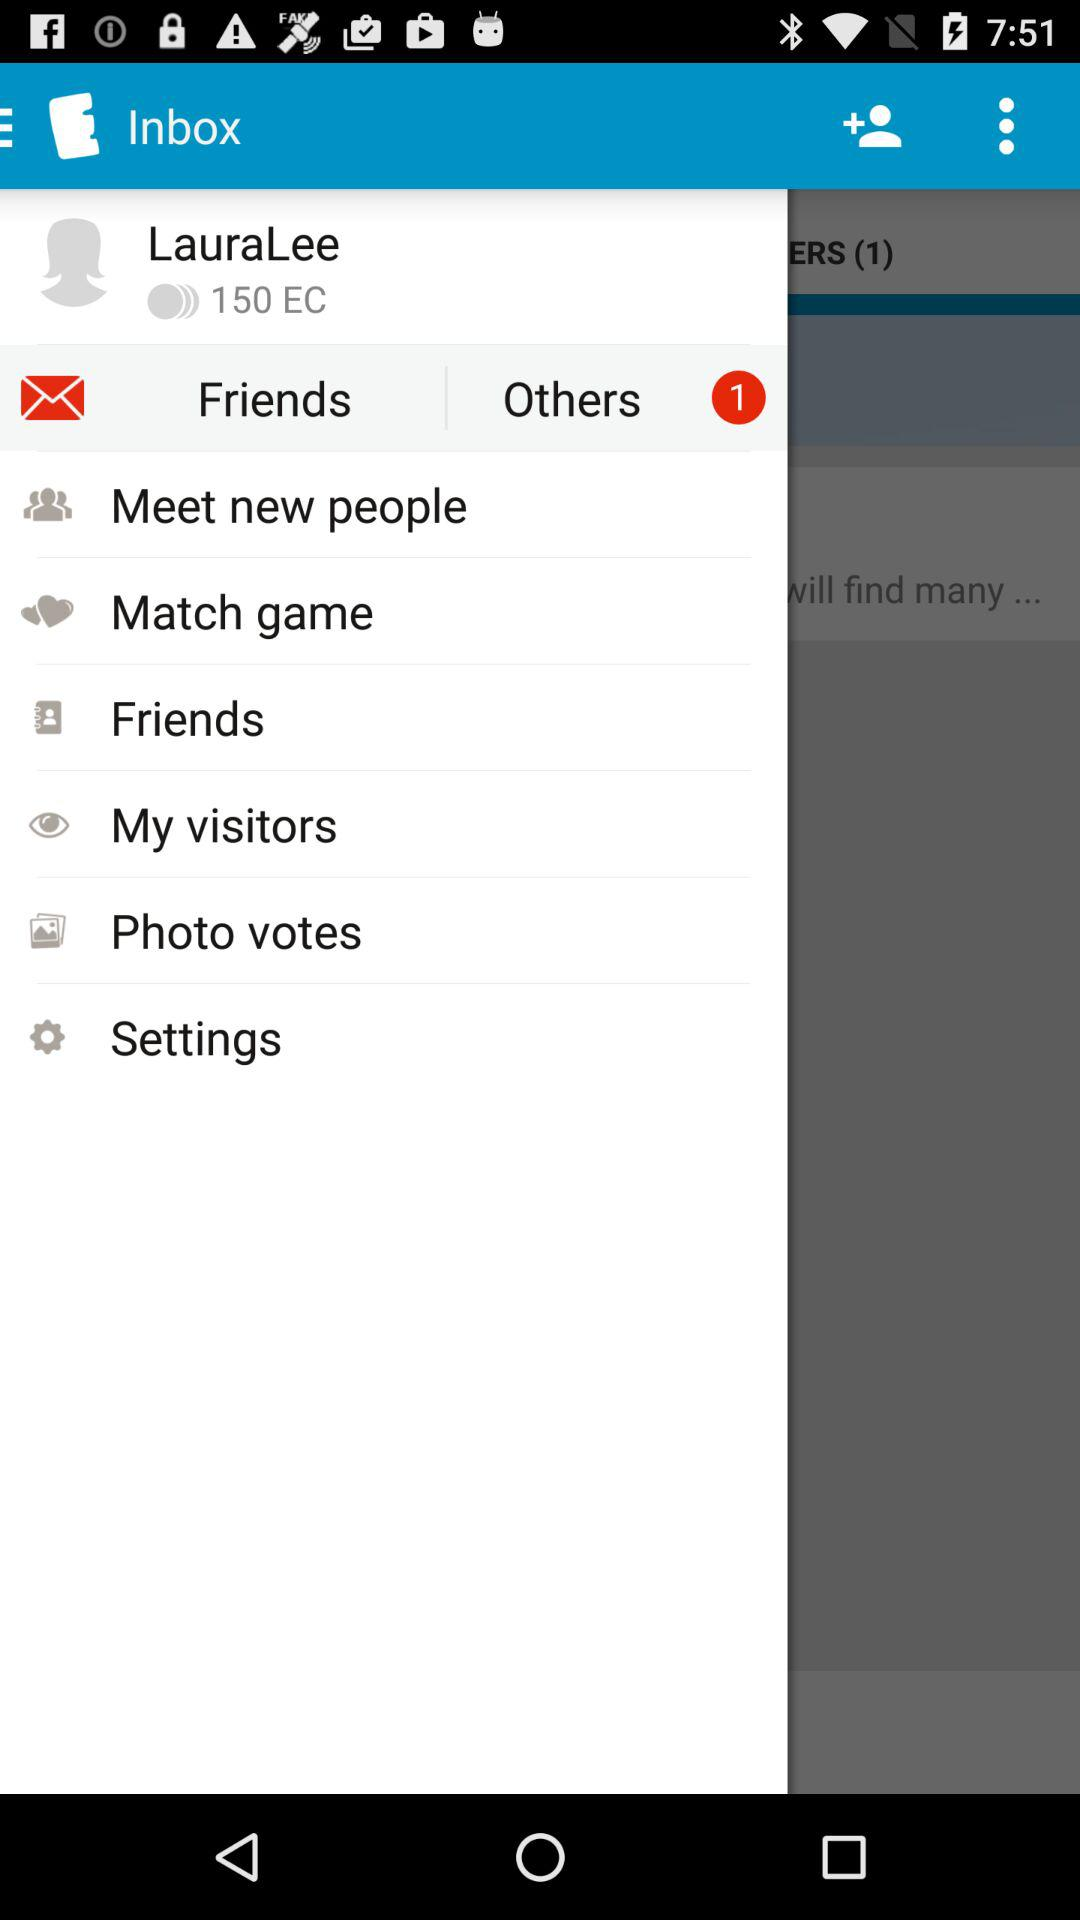What is the profile name? The profile name is "LauraLee". 